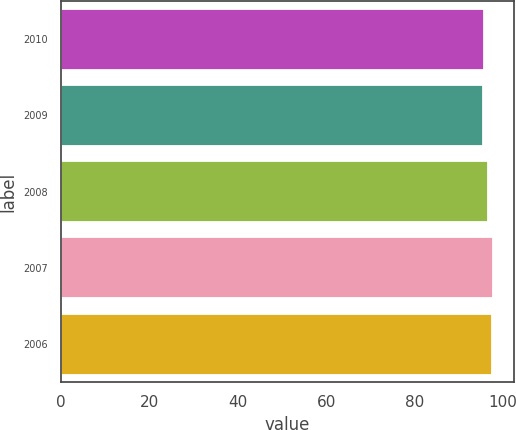Convert chart. <chart><loc_0><loc_0><loc_500><loc_500><bar_chart><fcel>2010<fcel>2009<fcel>2008<fcel>2007<fcel>2006<nl><fcel>95.71<fcel>95.5<fcel>96.7<fcel>97.71<fcel>97.5<nl></chart> 